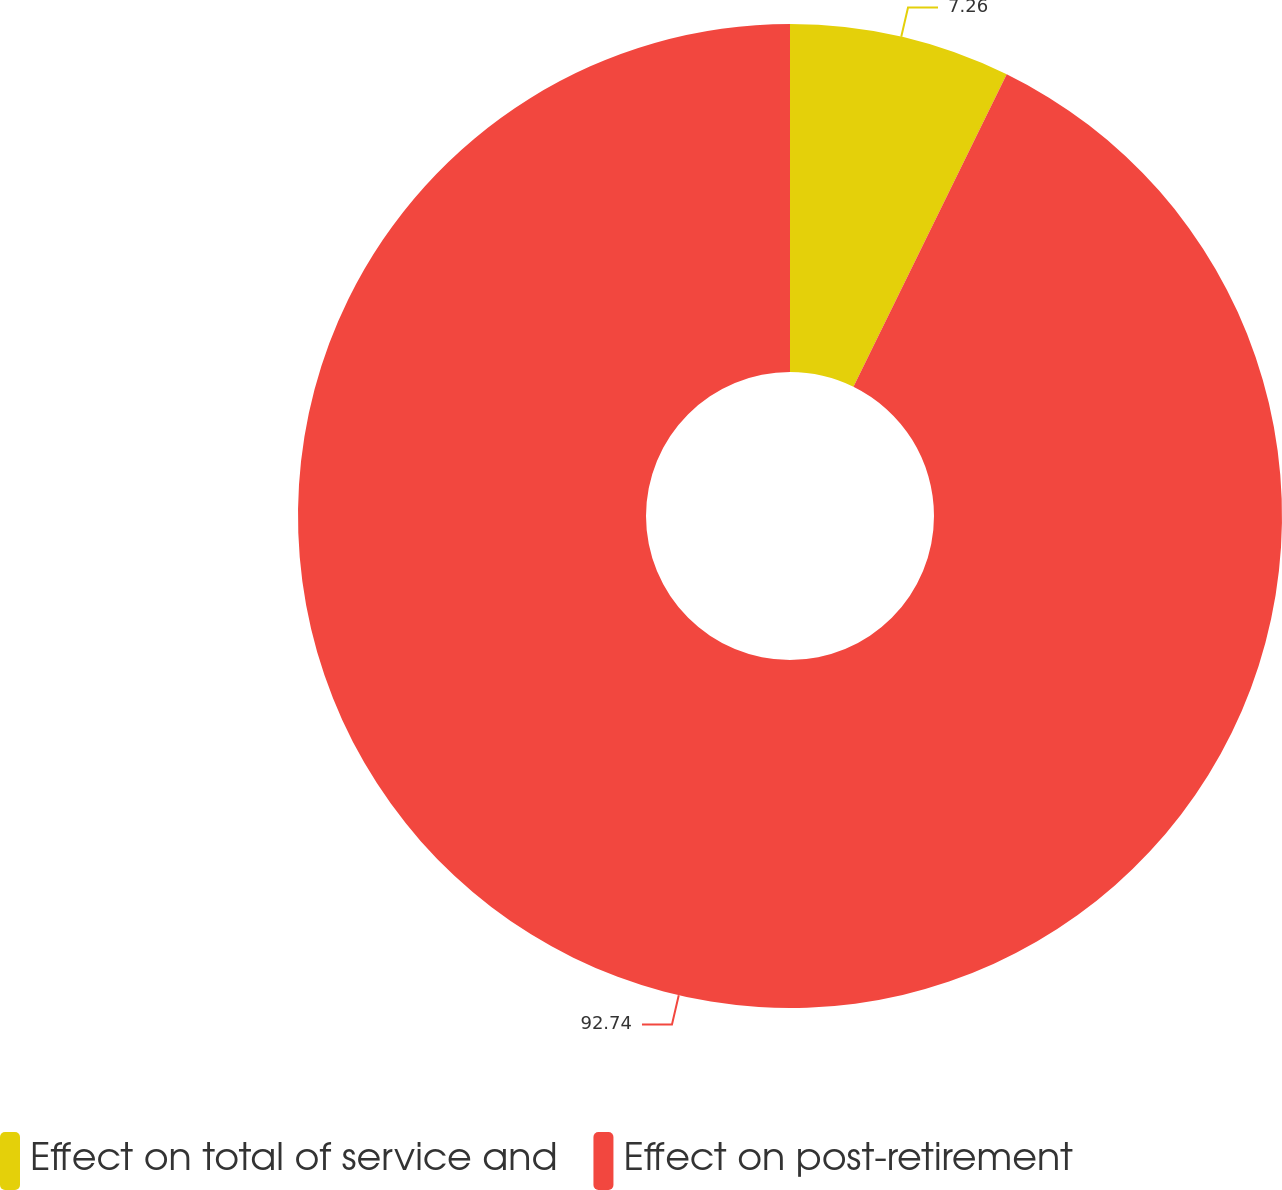Convert chart. <chart><loc_0><loc_0><loc_500><loc_500><pie_chart><fcel>Effect on total of service and<fcel>Effect on post-retirement<nl><fcel>7.26%<fcel>92.74%<nl></chart> 